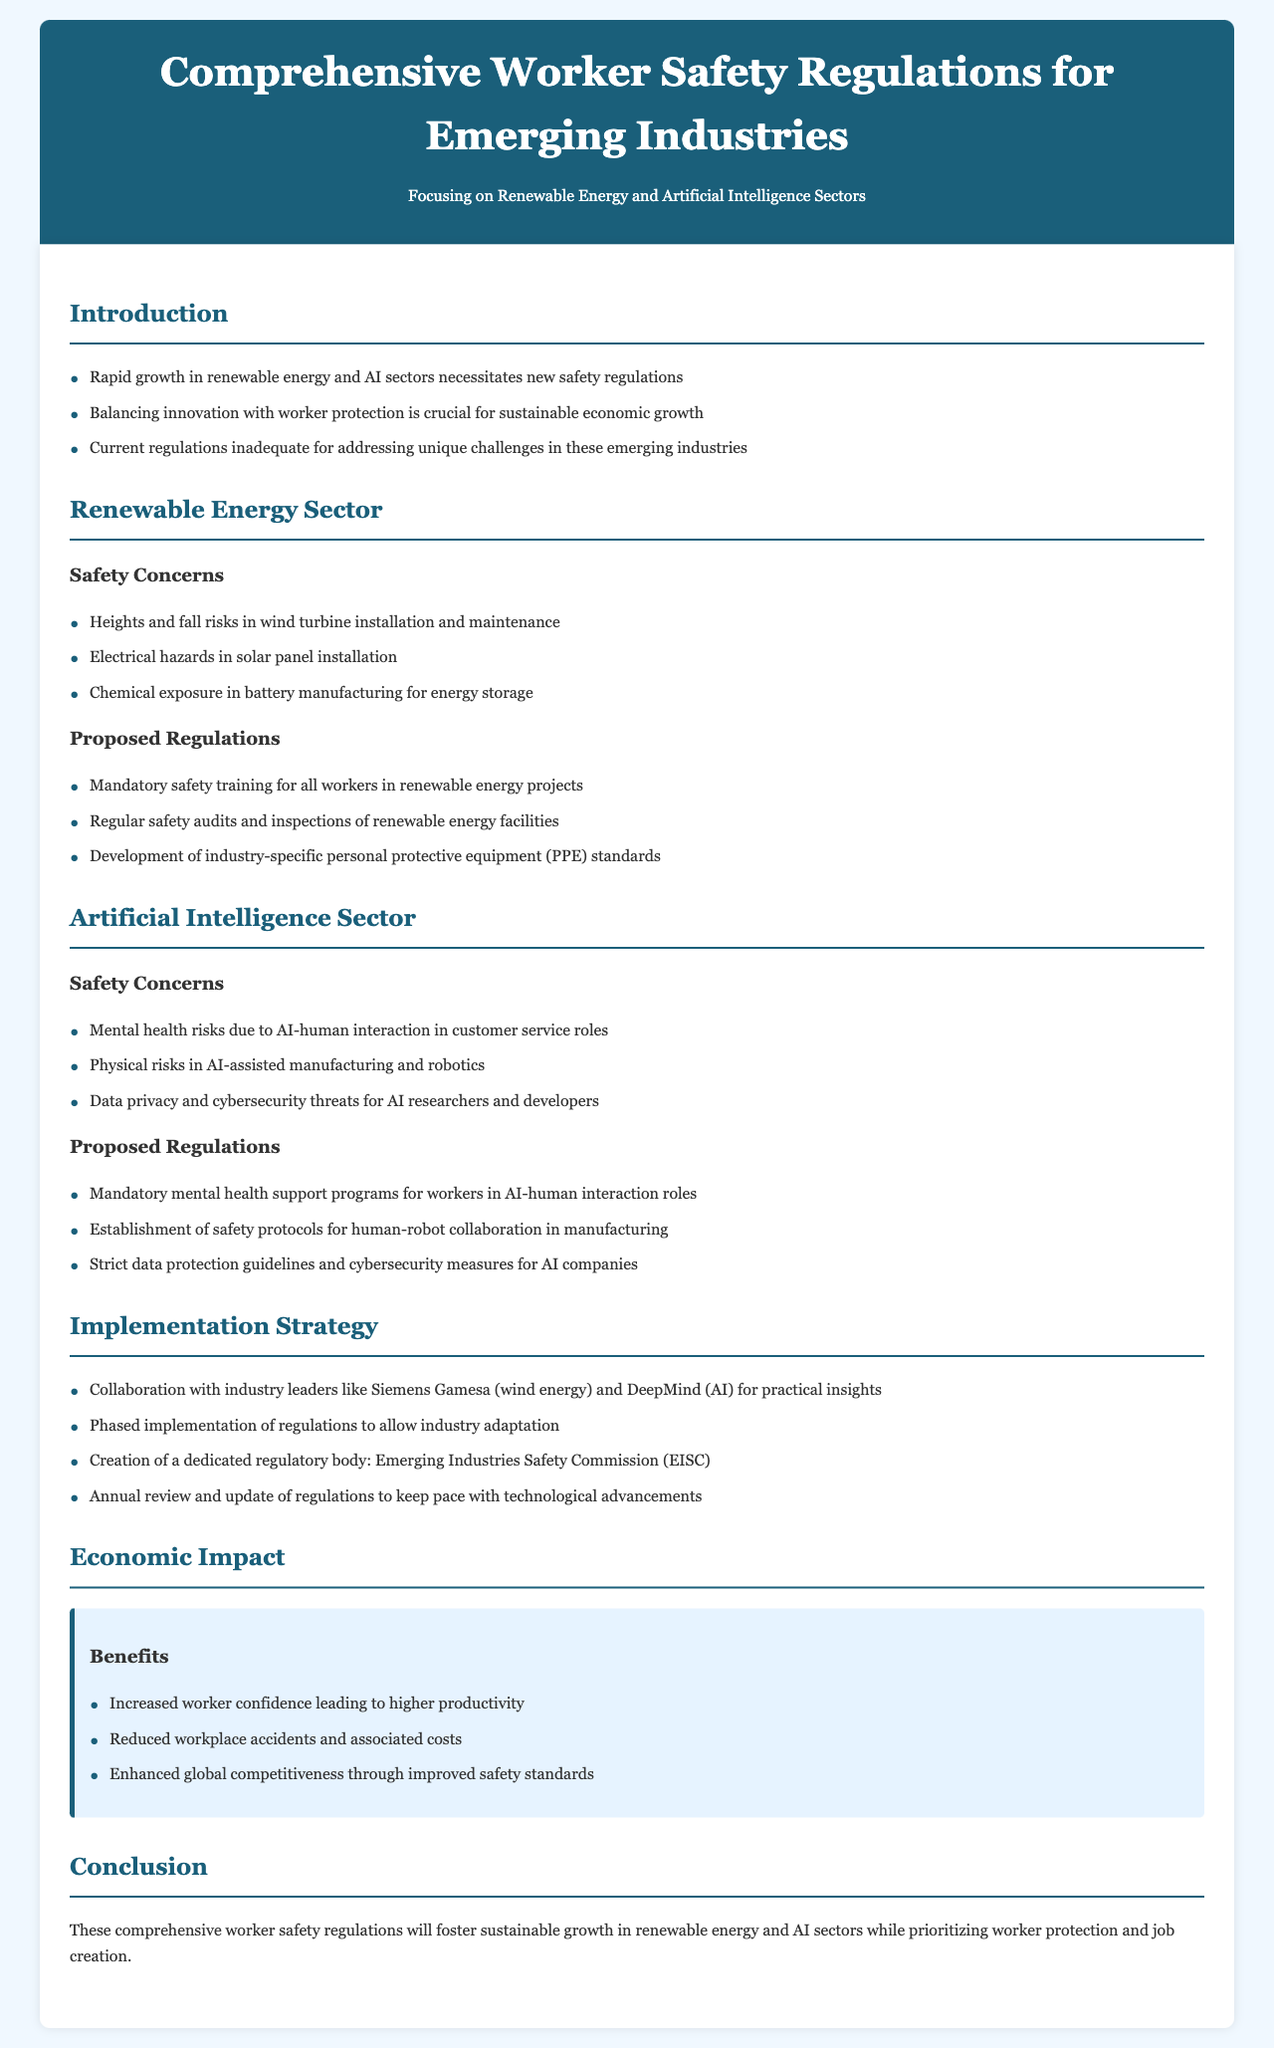What are the two sectors focused on in this document? The document specifically highlights the renewable energy and artificial intelligence sectors as areas of concern for worker safety regulations.
Answer: Renewable energy and artificial intelligence What is a major safety concern in the renewable energy sector? The document lists multiple safety concerns, one of which is heights and fall risks in wind turbine installation and maintenance.
Answer: Heights and fall risks What is a proposed regulation for AI workers? There are several proposed regulations, one of which includes mandatory mental health support programs for workers in AI-human interaction roles.
Answer: Mandatory mental health support programs What organization is proposed for regulation implementation? The document mentions the establishment of a dedicated regulatory body called the Emerging Industries Safety Commission (EISC) to oversee the implementation of these regulations.
Answer: Emerging Industries Safety Commission (EISC) What are the anticipated benefits of these regulations? The document states that benefits include increased worker confidence leading to higher productivity among other positive impacts.
Answer: Increased worker confidence What is a safety concern specific to AI-assisted manufacturing? The document notes that physical risks occur in AI-assisted manufacturing and robotics, highlighting safety challenges in this area.
Answer: Physical risks How many proposed regulations are listed for the renewable energy sector? There are three proposed regulations specifically mentioned for the renewable energy sector in the document.
Answer: Three What is the purpose of the proposed regulation review? The document states that the annual review and update of regulations will keep pace with technological advancements, ensuring relevancy and effectiveness.
Answer: To keep pace with technological advancements What highlights the need for new regulations in these sectors? The document indicates that the rapid growth in renewable energy and AI sectors necessitates new safety regulations to protect workers effectively.
Answer: Rapid growth in renewable energy and AI sectors 